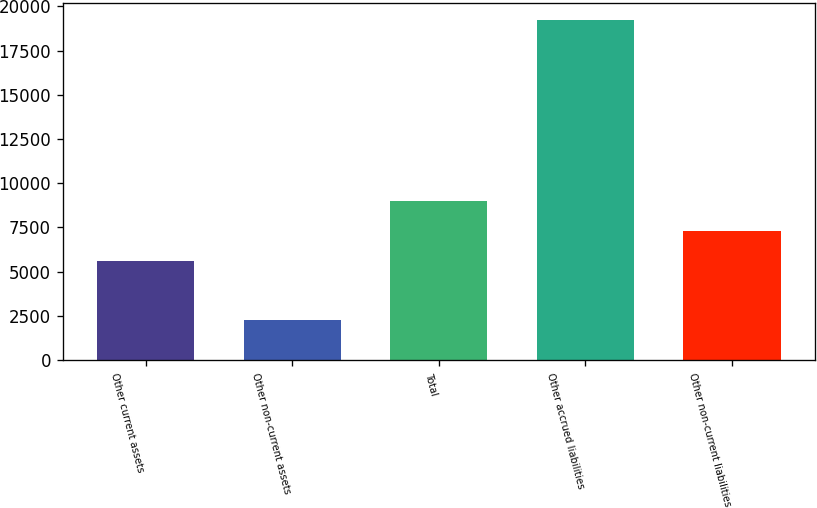Convert chart to OTSL. <chart><loc_0><loc_0><loc_500><loc_500><bar_chart><fcel>Other current assets<fcel>Other non-current assets<fcel>Total<fcel>Other accrued liabilities<fcel>Other non-current liabilities<nl><fcel>5596<fcel>2251<fcel>8991.2<fcel>19227<fcel>7293.6<nl></chart> 